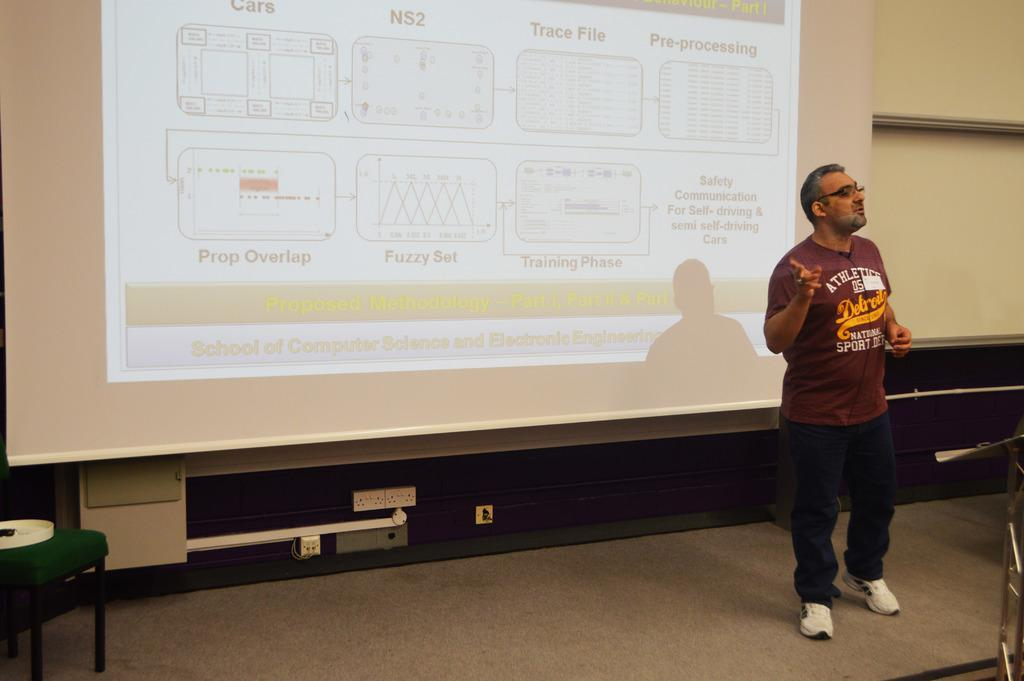<image>
Relay a brief, clear account of the picture shown. Man wearing a shirt which says "Detroit" on it giving a presentation. 